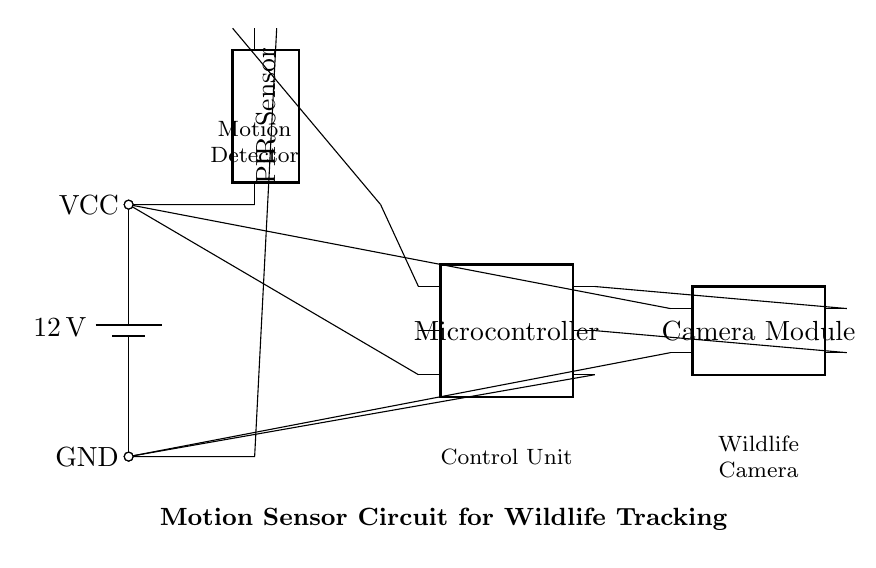What is the voltage supplied to the circuit? The voltage supplied to the circuit is 12 volts, as indicated by the battery labeled with 12V.
Answer: 12 volts What component detects motion in the circuit? The component that detects motion in the circuit is the PIR Sensor, as explicitly labeled in the diagram.
Answer: PIR Sensor How many pins does the microcontroller have? The microcontroller has six pins, which is shown in the circuit diagram labeled with the number of pins.
Answer: Six What is the role of the camera module in this circuit? The role of the camera module is to capture images or videos of detected motion, as implied by its connection to the microcontroller for processing.
Answer: Capture images Which component connects directly to the power supply? The PIR Sensor connects directly to the power supply, receiving its voltage supply from the battery at VCC.
Answer: PIR Sensor If the PIR sensor detects motion, which component is activated? If the PIR sensor detects motion, it activates the microcontroller, which processes the signal and controls the camera module accordingly.
Answer: Microcontroller What is the common ground connection for this circuit? The common ground connection for this circuit is the GND, which is shared by the PIR Sensor, microcontroller, and camera module.
Answer: GND 